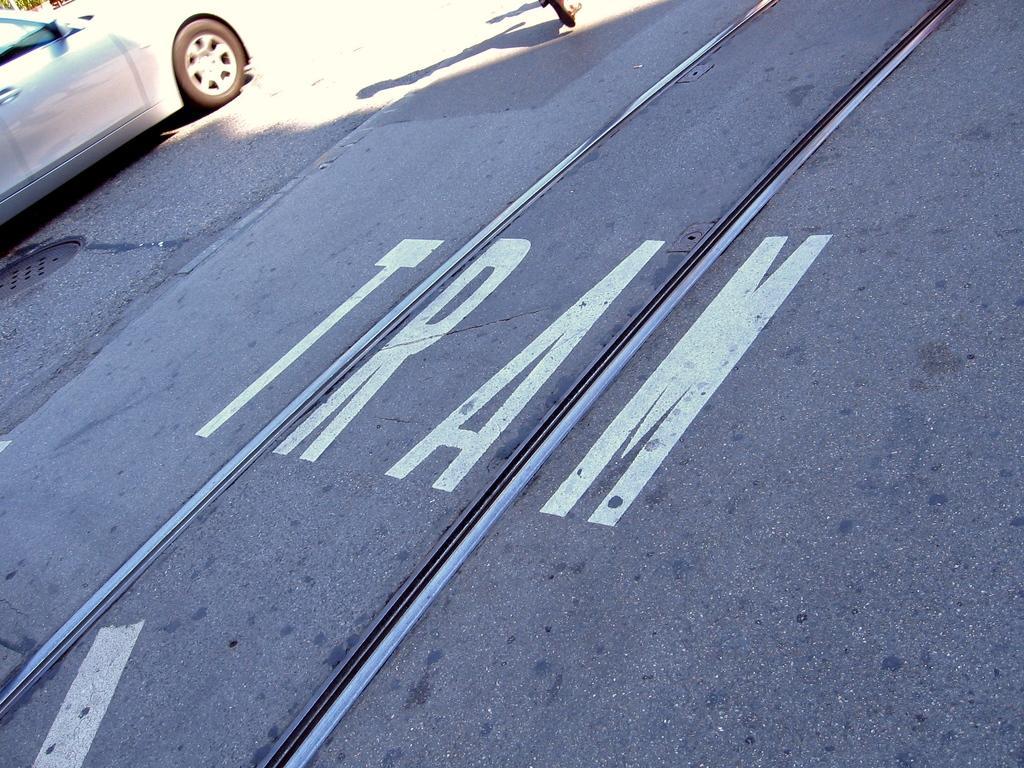Please provide a concise description of this image. As we can see in the image there is a road and white color car. 